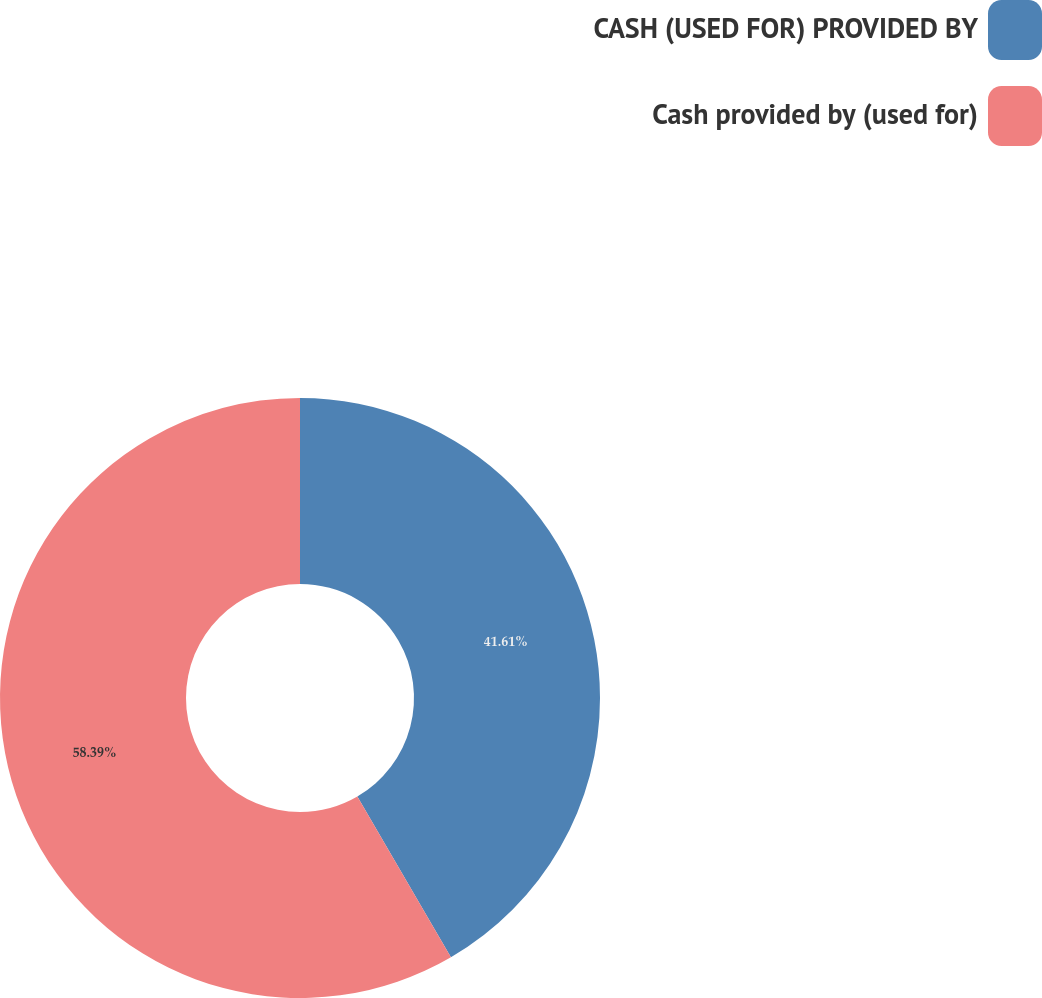Convert chart to OTSL. <chart><loc_0><loc_0><loc_500><loc_500><pie_chart><fcel>CASH (USED FOR) PROVIDED BY<fcel>Cash provided by (used for)<nl><fcel>41.61%<fcel>58.39%<nl></chart> 